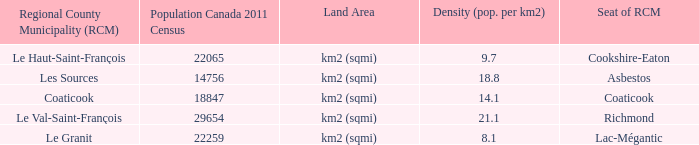Can you parse all the data within this table? {'header': ['Regional County Municipality (RCM)', 'Population Canada 2011 Census', 'Land Area', 'Density (pop. per km2)', 'Seat of RCM'], 'rows': [['Le Haut-Saint-François', '22065', 'km2 (sqmi)', '9.7', 'Cookshire-Eaton'], ['Les Sources', '14756', 'km2 (sqmi)', '18.8', 'Asbestos'], ['Coaticook', '18847', 'km2 (sqmi)', '14.1', 'Coaticook'], ['Le Val-Saint-François', '29654', 'km2 (sqmi)', '21.1', 'Richmond'], ['Le Granit', '22259', 'km2 (sqmi)', '8.1', 'Lac-Mégantic']]} What is the land area for the RCM that has a population of 18847? Km2 (sqmi). 